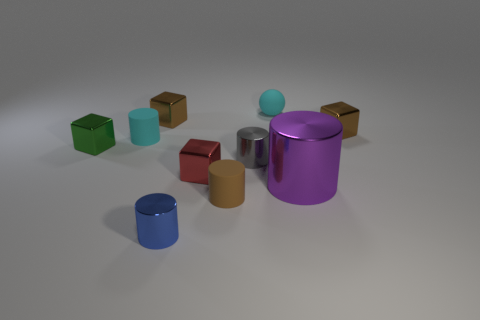Subtract all green cubes. How many cubes are left? 3 Subtract all yellow cylinders. How many brown blocks are left? 2 Subtract 1 cylinders. How many cylinders are left? 4 Subtract all red cubes. How many cubes are left? 3 Subtract all balls. How many objects are left? 9 Subtract 0 cyan cubes. How many objects are left? 10 Subtract all red blocks. Subtract all red cylinders. How many blocks are left? 3 Subtract all green balls. Subtract all blue objects. How many objects are left? 9 Add 7 red metallic blocks. How many red metallic blocks are left? 8 Add 6 brown matte objects. How many brown matte objects exist? 7 